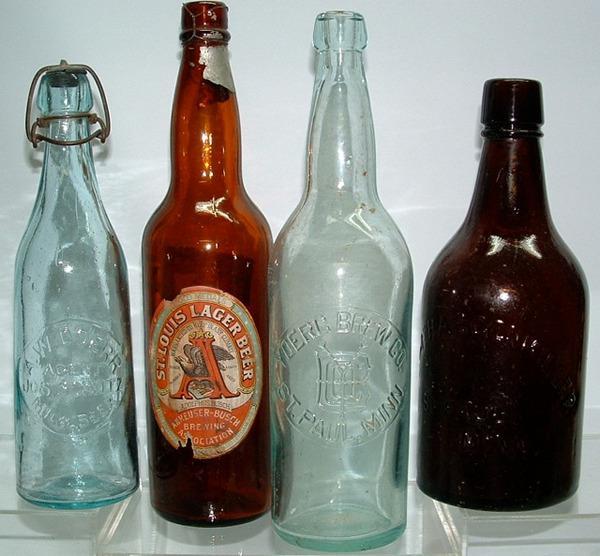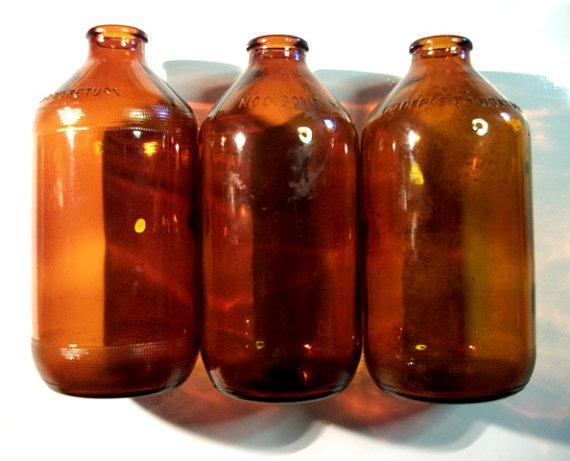The first image is the image on the left, the second image is the image on the right. Considering the images on both sides, is "In one image, three brown bottles have wide, squat bodies, and a small, rimmed top edge." valid? Answer yes or no. Yes. 